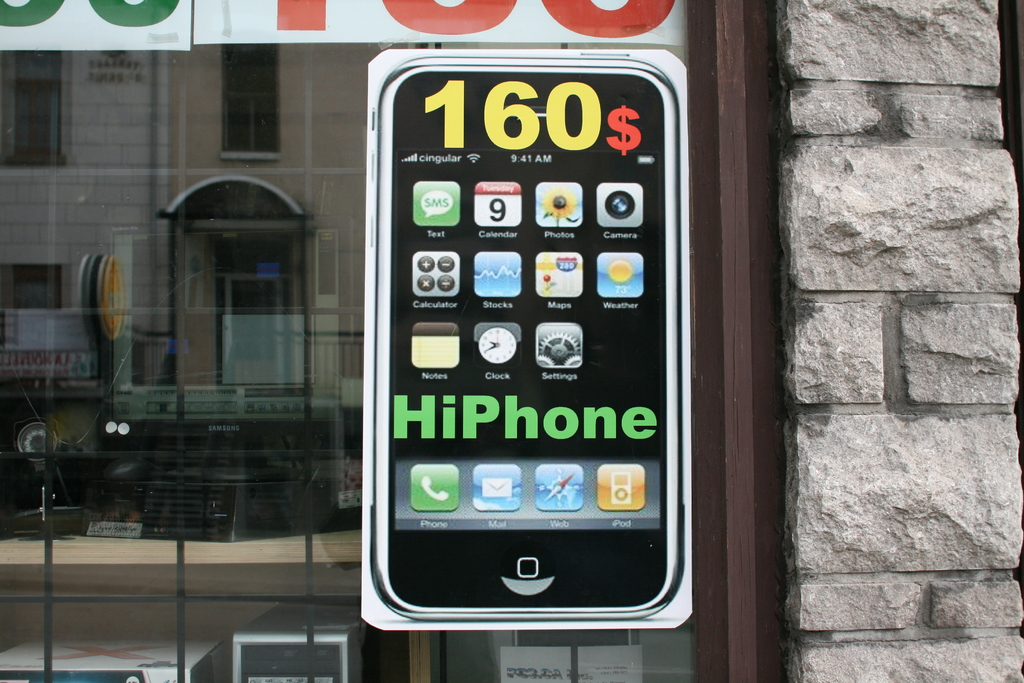Provide a one-sentence caption for the provided image. A striking storefront advertisement displays a large, mock smartphone priced at $160, cleverly capturing the attention of passersby with its oversized, realistic apps interface. 